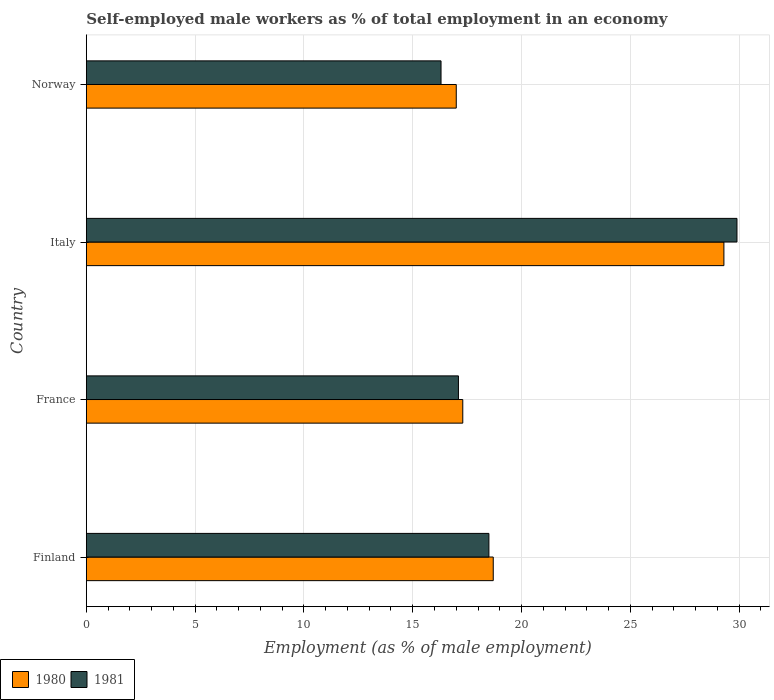How many groups of bars are there?
Ensure brevity in your answer.  4. Are the number of bars per tick equal to the number of legend labels?
Offer a terse response. Yes. What is the label of the 3rd group of bars from the top?
Offer a terse response. France. What is the percentage of self-employed male workers in 1980 in Finland?
Offer a terse response. 18.7. Across all countries, what is the maximum percentage of self-employed male workers in 1981?
Ensure brevity in your answer.  29.9. In which country was the percentage of self-employed male workers in 1980 minimum?
Provide a succinct answer. Norway. What is the total percentage of self-employed male workers in 1980 in the graph?
Your answer should be compact. 82.3. What is the difference between the percentage of self-employed male workers in 1981 in Italy and that in Norway?
Make the answer very short. 13.6. What is the difference between the percentage of self-employed male workers in 1980 in Norway and the percentage of self-employed male workers in 1981 in France?
Your response must be concise. -0.1. What is the average percentage of self-employed male workers in 1981 per country?
Your answer should be compact. 20.45. What is the difference between the percentage of self-employed male workers in 1981 and percentage of self-employed male workers in 1980 in Italy?
Offer a very short reply. 0.6. What is the ratio of the percentage of self-employed male workers in 1981 in Finland to that in Norway?
Your answer should be very brief. 1.13. What is the difference between the highest and the second highest percentage of self-employed male workers in 1980?
Your answer should be compact. 10.6. What is the difference between the highest and the lowest percentage of self-employed male workers in 1981?
Give a very brief answer. 13.6. Is the sum of the percentage of self-employed male workers in 1980 in France and Norway greater than the maximum percentage of self-employed male workers in 1981 across all countries?
Your response must be concise. Yes. What does the 1st bar from the top in Italy represents?
Your answer should be very brief. 1981. How many bars are there?
Give a very brief answer. 8. Are all the bars in the graph horizontal?
Provide a short and direct response. Yes. What is the difference between two consecutive major ticks on the X-axis?
Keep it short and to the point. 5. Are the values on the major ticks of X-axis written in scientific E-notation?
Offer a very short reply. No. Where does the legend appear in the graph?
Offer a very short reply. Bottom left. How many legend labels are there?
Ensure brevity in your answer.  2. How are the legend labels stacked?
Provide a short and direct response. Horizontal. What is the title of the graph?
Your answer should be very brief. Self-employed male workers as % of total employment in an economy. Does "1969" appear as one of the legend labels in the graph?
Keep it short and to the point. No. What is the label or title of the X-axis?
Your answer should be compact. Employment (as % of male employment). What is the label or title of the Y-axis?
Your answer should be compact. Country. What is the Employment (as % of male employment) in 1980 in Finland?
Your answer should be very brief. 18.7. What is the Employment (as % of male employment) in 1980 in France?
Your answer should be compact. 17.3. What is the Employment (as % of male employment) in 1981 in France?
Your response must be concise. 17.1. What is the Employment (as % of male employment) of 1980 in Italy?
Provide a short and direct response. 29.3. What is the Employment (as % of male employment) in 1981 in Italy?
Your answer should be compact. 29.9. What is the Employment (as % of male employment) in 1981 in Norway?
Your answer should be compact. 16.3. Across all countries, what is the maximum Employment (as % of male employment) in 1980?
Give a very brief answer. 29.3. Across all countries, what is the maximum Employment (as % of male employment) of 1981?
Keep it short and to the point. 29.9. Across all countries, what is the minimum Employment (as % of male employment) in 1981?
Your answer should be very brief. 16.3. What is the total Employment (as % of male employment) in 1980 in the graph?
Give a very brief answer. 82.3. What is the total Employment (as % of male employment) of 1981 in the graph?
Your answer should be compact. 81.8. What is the difference between the Employment (as % of male employment) in 1981 in Finland and that in Italy?
Keep it short and to the point. -11.4. What is the difference between the Employment (as % of male employment) in 1980 in Finland and that in Norway?
Your response must be concise. 1.7. What is the difference between the Employment (as % of male employment) in 1981 in Finland and that in Norway?
Offer a very short reply. 2.2. What is the difference between the Employment (as % of male employment) of 1980 in France and that in Italy?
Provide a succinct answer. -12. What is the difference between the Employment (as % of male employment) in 1981 in France and that in Italy?
Your answer should be compact. -12.8. What is the difference between the Employment (as % of male employment) in 1980 in France and that in Norway?
Keep it short and to the point. 0.3. What is the difference between the Employment (as % of male employment) in 1980 in Italy and that in Norway?
Offer a very short reply. 12.3. What is the difference between the Employment (as % of male employment) of 1980 in Finland and the Employment (as % of male employment) of 1981 in France?
Keep it short and to the point. 1.6. What is the difference between the Employment (as % of male employment) in 1980 in Finland and the Employment (as % of male employment) in 1981 in Italy?
Your answer should be very brief. -11.2. What is the difference between the Employment (as % of male employment) of 1980 in France and the Employment (as % of male employment) of 1981 in Italy?
Your answer should be compact. -12.6. What is the difference between the Employment (as % of male employment) in 1980 in France and the Employment (as % of male employment) in 1981 in Norway?
Your answer should be very brief. 1. What is the difference between the Employment (as % of male employment) in 1980 in Italy and the Employment (as % of male employment) in 1981 in Norway?
Offer a terse response. 13. What is the average Employment (as % of male employment) in 1980 per country?
Your answer should be very brief. 20.57. What is the average Employment (as % of male employment) in 1981 per country?
Your answer should be compact. 20.45. What is the difference between the Employment (as % of male employment) of 1980 and Employment (as % of male employment) of 1981 in Finland?
Offer a terse response. 0.2. What is the difference between the Employment (as % of male employment) of 1980 and Employment (as % of male employment) of 1981 in France?
Your response must be concise. 0.2. What is the ratio of the Employment (as % of male employment) of 1980 in Finland to that in France?
Your response must be concise. 1.08. What is the ratio of the Employment (as % of male employment) in 1981 in Finland to that in France?
Provide a succinct answer. 1.08. What is the ratio of the Employment (as % of male employment) of 1980 in Finland to that in Italy?
Provide a short and direct response. 0.64. What is the ratio of the Employment (as % of male employment) in 1981 in Finland to that in Italy?
Your response must be concise. 0.62. What is the ratio of the Employment (as % of male employment) of 1980 in Finland to that in Norway?
Your response must be concise. 1.1. What is the ratio of the Employment (as % of male employment) in 1981 in Finland to that in Norway?
Make the answer very short. 1.14. What is the ratio of the Employment (as % of male employment) of 1980 in France to that in Italy?
Make the answer very short. 0.59. What is the ratio of the Employment (as % of male employment) in 1981 in France to that in Italy?
Offer a very short reply. 0.57. What is the ratio of the Employment (as % of male employment) of 1980 in France to that in Norway?
Your response must be concise. 1.02. What is the ratio of the Employment (as % of male employment) of 1981 in France to that in Norway?
Provide a short and direct response. 1.05. What is the ratio of the Employment (as % of male employment) of 1980 in Italy to that in Norway?
Give a very brief answer. 1.72. What is the ratio of the Employment (as % of male employment) of 1981 in Italy to that in Norway?
Give a very brief answer. 1.83. What is the difference between the highest and the second highest Employment (as % of male employment) of 1981?
Ensure brevity in your answer.  11.4. What is the difference between the highest and the lowest Employment (as % of male employment) in 1980?
Make the answer very short. 12.3. 